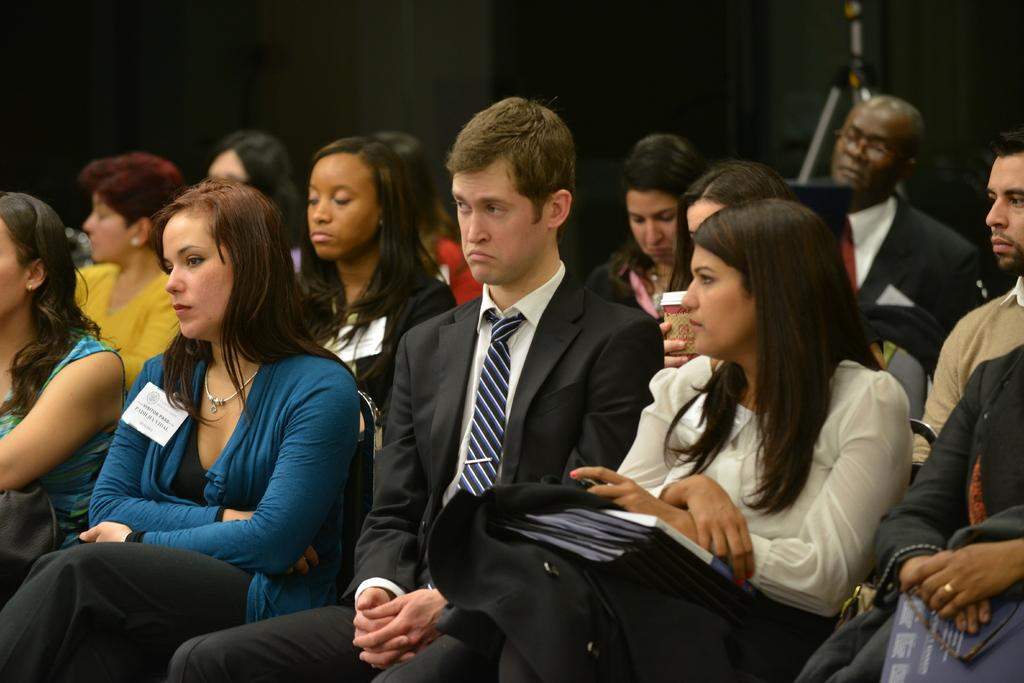How many persons are in the image? There are persons in the image, but the exact number is not specified. What is one object that can be seen in the image? There is a book in the image. Can you describe any other objects in the image? There are other objects in the image, but their specific details are not provided. What can be seen in the background of the image? There is a wall and a stand in the background of the image. Are there any other objects visible in the background? Yes, there are other objects in the background of the image. What type of science experiment is being conducted with the zebra in the image? There is no zebra present in the image, and therefore no science experiment involving a zebra can be observed. 